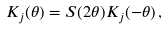<formula> <loc_0><loc_0><loc_500><loc_500>K _ { j } ( \theta ) = S ( 2 \theta ) K _ { j } ( - \theta ) \, ,</formula> 